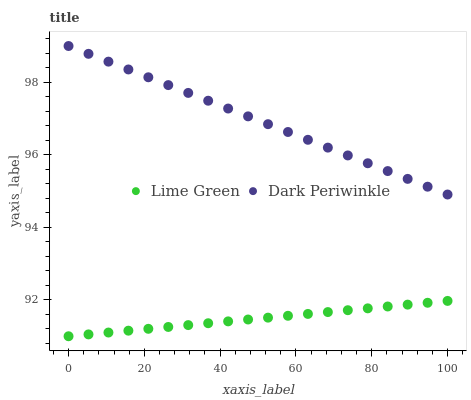Does Lime Green have the minimum area under the curve?
Answer yes or no. Yes. Does Dark Periwinkle have the maximum area under the curve?
Answer yes or no. Yes. Does Dark Periwinkle have the minimum area under the curve?
Answer yes or no. No. Is Dark Periwinkle the smoothest?
Answer yes or no. Yes. Is Lime Green the roughest?
Answer yes or no. Yes. Is Dark Periwinkle the roughest?
Answer yes or no. No. Does Lime Green have the lowest value?
Answer yes or no. Yes. Does Dark Periwinkle have the lowest value?
Answer yes or no. No. Does Dark Periwinkle have the highest value?
Answer yes or no. Yes. Is Lime Green less than Dark Periwinkle?
Answer yes or no. Yes. Is Dark Periwinkle greater than Lime Green?
Answer yes or no. Yes. Does Lime Green intersect Dark Periwinkle?
Answer yes or no. No. 